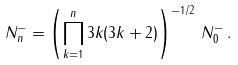<formula> <loc_0><loc_0><loc_500><loc_500>N _ { n } ^ { - } = \left ( \prod _ { k = 1 } ^ { n } 3 k ( 3 k + 2 ) \right ) ^ { - 1 / 2 } \, N _ { 0 } ^ { - } \, .</formula> 